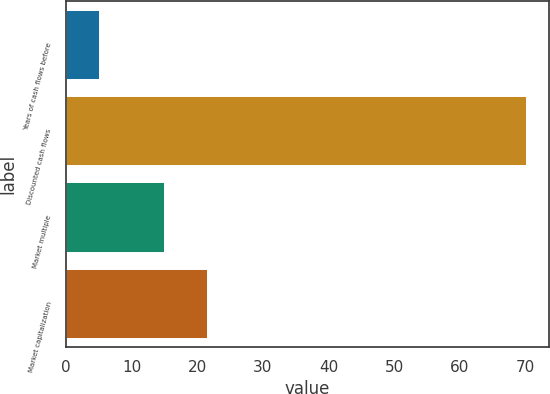<chart> <loc_0><loc_0><loc_500><loc_500><bar_chart><fcel>Years of cash flows before<fcel>Discounted cash flows<fcel>Market multiple<fcel>Market capitalization<nl><fcel>5<fcel>70<fcel>15<fcel>21.5<nl></chart> 